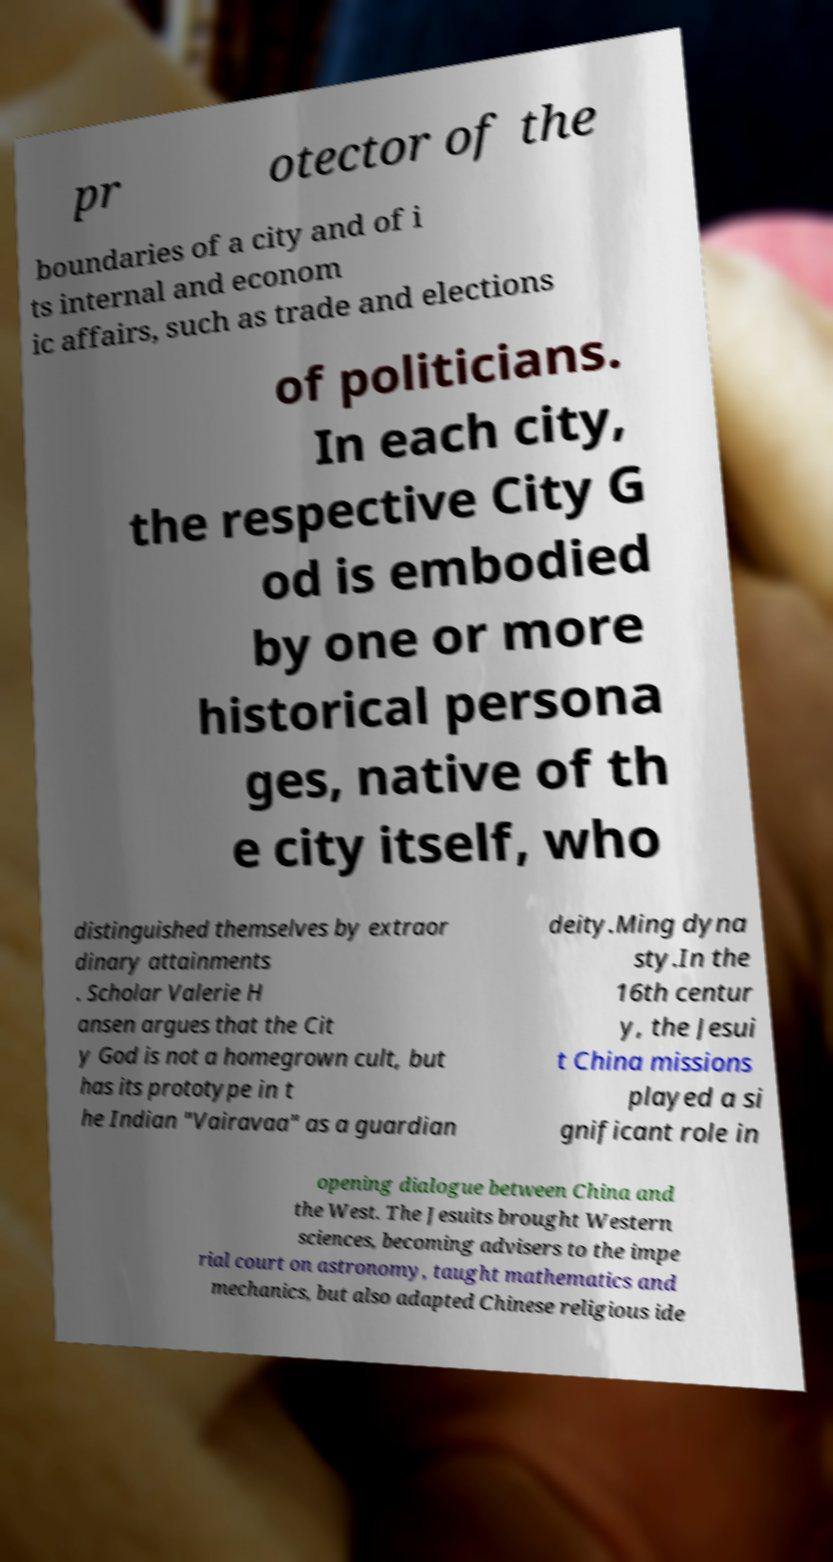For documentation purposes, I need the text within this image transcribed. Could you provide that? pr otector of the boundaries of a city and of i ts internal and econom ic affairs, such as trade and elections of politicians. In each city, the respective City G od is embodied by one or more historical persona ges, native of th e city itself, who distinguished themselves by extraor dinary attainments . Scholar Valerie H ansen argues that the Cit y God is not a homegrown cult, but has its prototype in t he Indian "Vairavaa" as a guardian deity.Ming dyna sty.In the 16th centur y, the Jesui t China missions played a si gnificant role in opening dialogue between China and the West. The Jesuits brought Western sciences, becoming advisers to the impe rial court on astronomy, taught mathematics and mechanics, but also adapted Chinese religious ide 